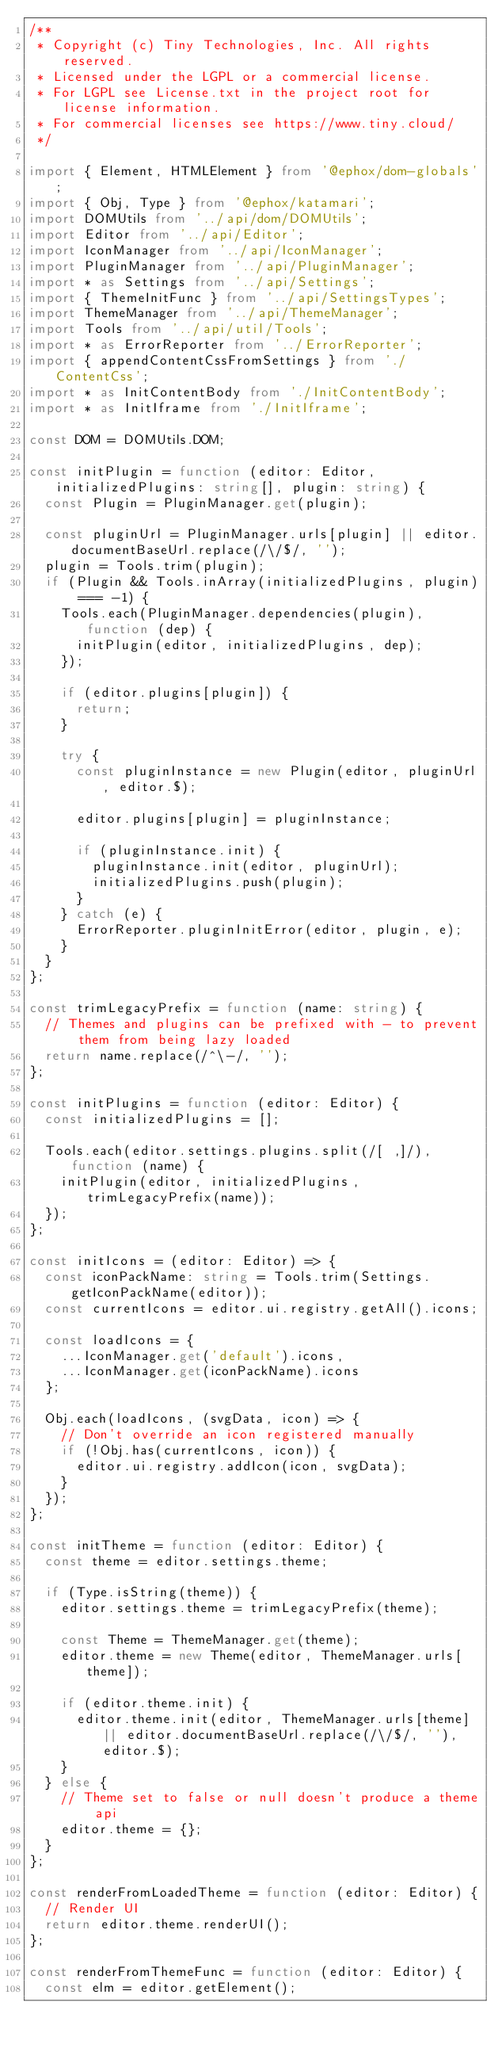Convert code to text. <code><loc_0><loc_0><loc_500><loc_500><_TypeScript_>/**
 * Copyright (c) Tiny Technologies, Inc. All rights reserved.
 * Licensed under the LGPL or a commercial license.
 * For LGPL see License.txt in the project root for license information.
 * For commercial licenses see https://www.tiny.cloud/
 */

import { Element, HTMLElement } from '@ephox/dom-globals';
import { Obj, Type } from '@ephox/katamari';
import DOMUtils from '../api/dom/DOMUtils';
import Editor from '../api/Editor';
import IconManager from '../api/IconManager';
import PluginManager from '../api/PluginManager';
import * as Settings from '../api/Settings';
import { ThemeInitFunc } from '../api/SettingsTypes';
import ThemeManager from '../api/ThemeManager';
import Tools from '../api/util/Tools';
import * as ErrorReporter from '../ErrorReporter';
import { appendContentCssFromSettings } from './ContentCss';
import * as InitContentBody from './InitContentBody';
import * as InitIframe from './InitIframe';

const DOM = DOMUtils.DOM;

const initPlugin = function (editor: Editor, initializedPlugins: string[], plugin: string) {
  const Plugin = PluginManager.get(plugin);

  const pluginUrl = PluginManager.urls[plugin] || editor.documentBaseUrl.replace(/\/$/, '');
  plugin = Tools.trim(plugin);
  if (Plugin && Tools.inArray(initializedPlugins, plugin) === -1) {
    Tools.each(PluginManager.dependencies(plugin), function (dep) {
      initPlugin(editor, initializedPlugins, dep);
    });

    if (editor.plugins[plugin]) {
      return;
    }

    try {
      const pluginInstance = new Plugin(editor, pluginUrl, editor.$);

      editor.plugins[plugin] = pluginInstance;

      if (pluginInstance.init) {
        pluginInstance.init(editor, pluginUrl);
        initializedPlugins.push(plugin);
      }
    } catch (e) {
      ErrorReporter.pluginInitError(editor, plugin, e);
    }
  }
};

const trimLegacyPrefix = function (name: string) {
  // Themes and plugins can be prefixed with - to prevent them from being lazy loaded
  return name.replace(/^\-/, '');
};

const initPlugins = function (editor: Editor) {
  const initializedPlugins = [];

  Tools.each(editor.settings.plugins.split(/[ ,]/), function (name) {
    initPlugin(editor, initializedPlugins, trimLegacyPrefix(name));
  });
};

const initIcons = (editor: Editor) => {
  const iconPackName: string = Tools.trim(Settings.getIconPackName(editor));
  const currentIcons = editor.ui.registry.getAll().icons;

  const loadIcons = {
    ...IconManager.get('default').icons,
    ...IconManager.get(iconPackName).icons
  };

  Obj.each(loadIcons, (svgData, icon) => {
    // Don't override an icon registered manually
    if (!Obj.has(currentIcons, icon)) {
      editor.ui.registry.addIcon(icon, svgData);
    }
  });
};

const initTheme = function (editor: Editor) {
  const theme = editor.settings.theme;

  if (Type.isString(theme)) {
    editor.settings.theme = trimLegacyPrefix(theme);

    const Theme = ThemeManager.get(theme);
    editor.theme = new Theme(editor, ThemeManager.urls[theme]);

    if (editor.theme.init) {
      editor.theme.init(editor, ThemeManager.urls[theme] || editor.documentBaseUrl.replace(/\/$/, ''), editor.$);
    }
  } else {
    // Theme set to false or null doesn't produce a theme api
    editor.theme = {};
  }
};

const renderFromLoadedTheme = function (editor: Editor) {
  // Render UI
  return editor.theme.renderUI();
};

const renderFromThemeFunc = function (editor: Editor) {
  const elm = editor.getElement();</code> 